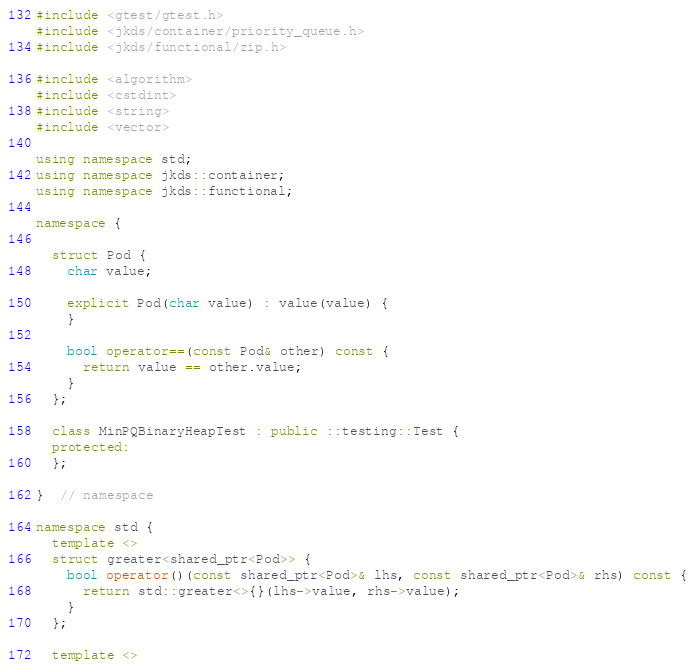<code> <loc_0><loc_0><loc_500><loc_500><_C++_>#include <gtest/gtest.h>
#include <jkds/container/priority_queue.h>
#include <jkds/functional/zip.h>

#include <algorithm>
#include <cstdint>
#include <string>
#include <vector>

using namespace std;
using namespace jkds::container;
using namespace jkds::functional;

namespace {

  struct Pod {
    char value;

    explicit Pod(char value) : value(value) {
    }

    bool operator==(const Pod& other) const {
      return value == other.value;
    }
  };

  class MinPQBinaryHeapTest : public ::testing::Test {
  protected:
  };

}  // namespace

namespace std {
  template <>
  struct greater<shared_ptr<Pod>> {
    bool operator()(const shared_ptr<Pod>& lhs, const shared_ptr<Pod>& rhs) const {
      return std::greater<>{}(lhs->value, rhs->value);
    }
  };

  template <></code> 